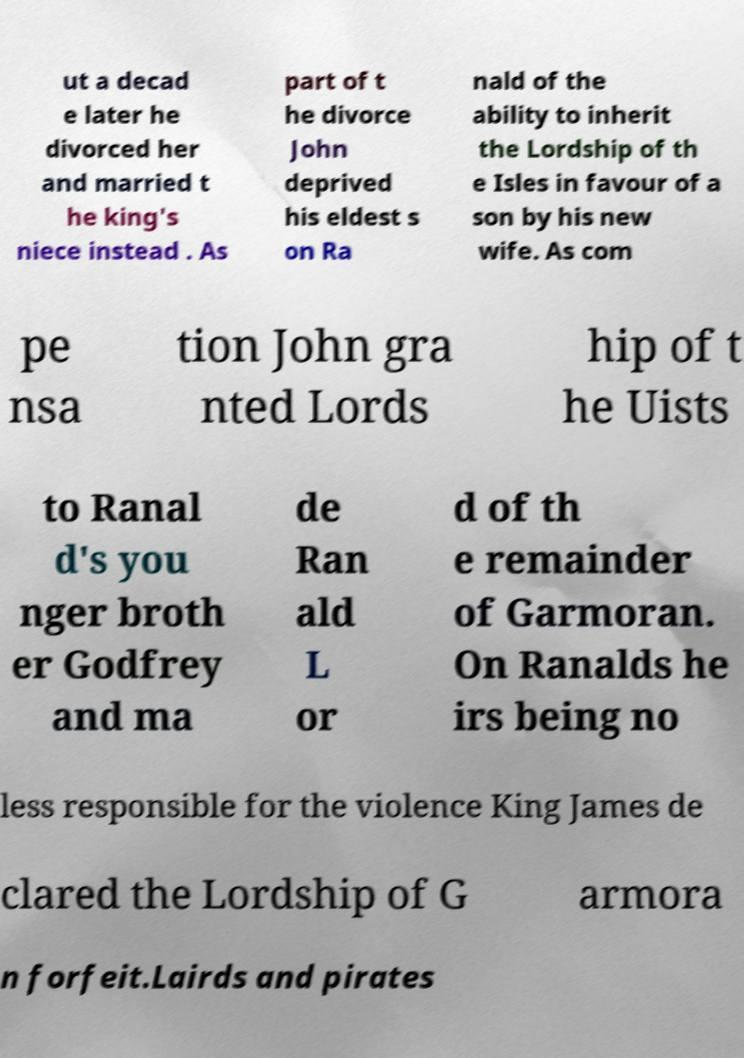There's text embedded in this image that I need extracted. Can you transcribe it verbatim? ut a decad e later he divorced her and married t he king's niece instead . As part of t he divorce John deprived his eldest s on Ra nald of the ability to inherit the Lordship of th e Isles in favour of a son by his new wife. As com pe nsa tion John gra nted Lords hip of t he Uists to Ranal d's you nger broth er Godfrey and ma de Ran ald L or d of th e remainder of Garmoran. On Ranalds he irs being no less responsible for the violence King James de clared the Lordship of G armora n forfeit.Lairds and pirates 